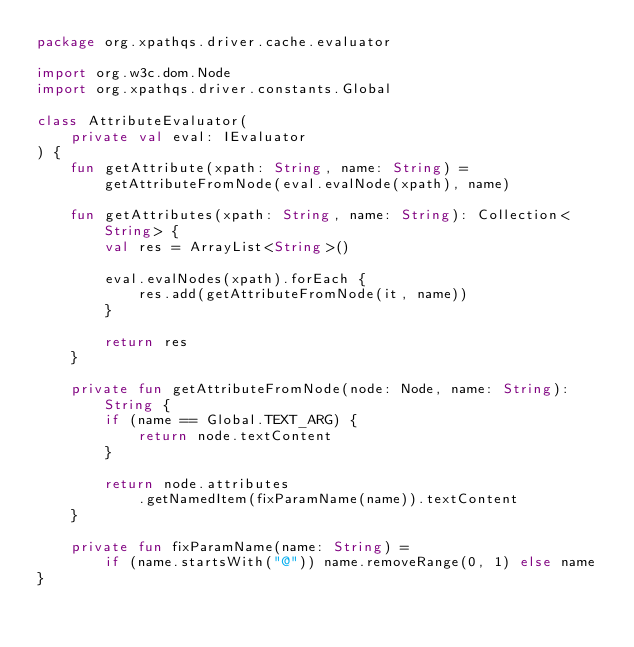<code> <loc_0><loc_0><loc_500><loc_500><_Kotlin_>package org.xpathqs.driver.cache.evaluator

import org.w3c.dom.Node
import org.xpathqs.driver.constants.Global

class AttributeEvaluator(
    private val eval: IEvaluator
) {
    fun getAttribute(xpath: String, name: String) =
        getAttributeFromNode(eval.evalNode(xpath), name)

    fun getAttributes(xpath: String, name: String): Collection<String> {
        val res = ArrayList<String>()

        eval.evalNodes(xpath).forEach {
            res.add(getAttributeFromNode(it, name))
        }

        return res
    }

    private fun getAttributeFromNode(node: Node, name: String): String {
        if (name == Global.TEXT_ARG) {
            return node.textContent
        }

        return node.attributes
            .getNamedItem(fixParamName(name)).textContent
    }

    private fun fixParamName(name: String) =
        if (name.startsWith("@")) name.removeRange(0, 1) else name
}</code> 